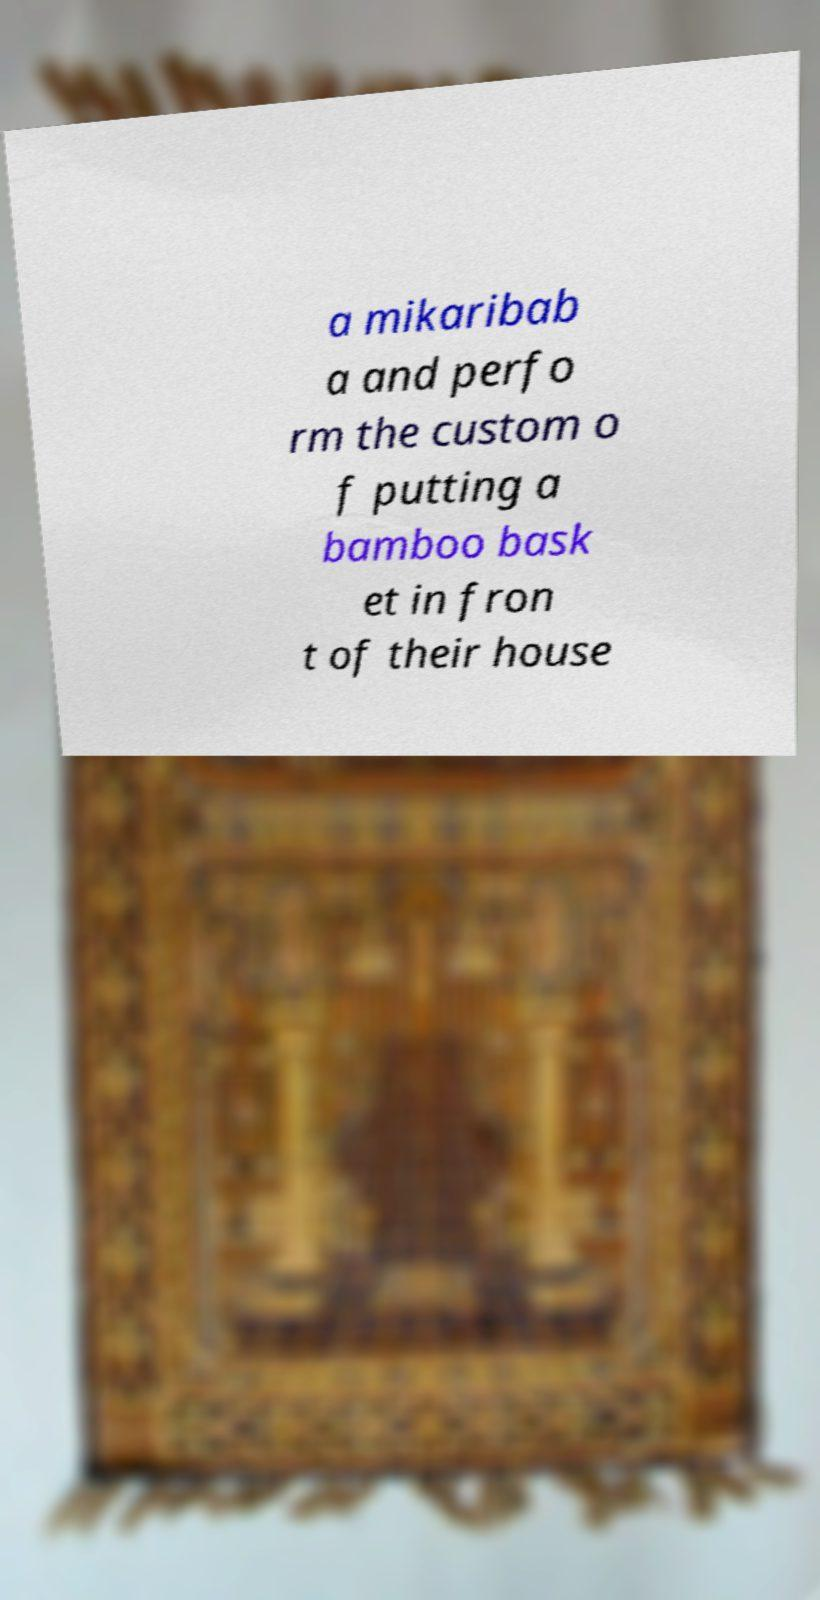Can you accurately transcribe the text from the provided image for me? a mikaribab a and perfo rm the custom o f putting a bamboo bask et in fron t of their house 